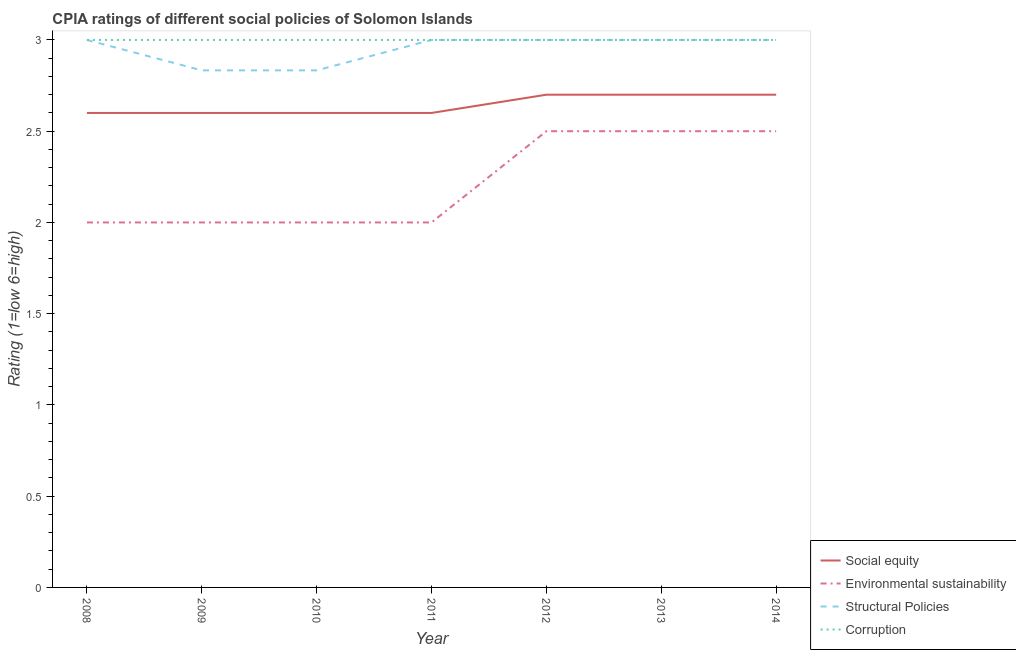Is the number of lines equal to the number of legend labels?
Ensure brevity in your answer.  Yes. Across all years, what is the maximum cpia rating of structural policies?
Your response must be concise. 3. Across all years, what is the minimum cpia rating of social equity?
Offer a very short reply. 2.6. In which year was the cpia rating of environmental sustainability maximum?
Provide a short and direct response. 2012. In which year was the cpia rating of corruption minimum?
Your answer should be very brief. 2008. What is the total cpia rating of social equity in the graph?
Your answer should be very brief. 18.5. What is the difference between the cpia rating of structural policies in 2009 and that in 2014?
Your answer should be compact. -0.17. What is the average cpia rating of environmental sustainability per year?
Your answer should be compact. 2.21. In the year 2011, what is the difference between the cpia rating of social equity and cpia rating of corruption?
Provide a short and direct response. -0.4. What is the ratio of the cpia rating of structural policies in 2010 to that in 2011?
Your answer should be very brief. 0.94. Is the difference between the cpia rating of environmental sustainability in 2008 and 2014 greater than the difference between the cpia rating of social equity in 2008 and 2014?
Make the answer very short. No. What is the difference between the highest and the second highest cpia rating of social equity?
Offer a very short reply. 0. What is the difference between the highest and the lowest cpia rating of structural policies?
Make the answer very short. 0.17. In how many years, is the cpia rating of corruption greater than the average cpia rating of corruption taken over all years?
Provide a succinct answer. 0. Is the sum of the cpia rating of environmental sustainability in 2008 and 2011 greater than the maximum cpia rating of corruption across all years?
Keep it short and to the point. Yes. Is it the case that in every year, the sum of the cpia rating of social equity and cpia rating of environmental sustainability is greater than the cpia rating of structural policies?
Offer a very short reply. Yes. What is the difference between two consecutive major ticks on the Y-axis?
Keep it short and to the point. 0.5. Does the graph contain any zero values?
Provide a succinct answer. No. Does the graph contain grids?
Offer a terse response. No. Where does the legend appear in the graph?
Offer a terse response. Bottom right. How many legend labels are there?
Your answer should be very brief. 4. How are the legend labels stacked?
Your answer should be very brief. Vertical. What is the title of the graph?
Your answer should be compact. CPIA ratings of different social policies of Solomon Islands. Does "Minerals" appear as one of the legend labels in the graph?
Give a very brief answer. No. What is the label or title of the Y-axis?
Offer a terse response. Rating (1=low 6=high). What is the Rating (1=low 6=high) of Corruption in 2008?
Provide a short and direct response. 3. What is the Rating (1=low 6=high) of Structural Policies in 2009?
Provide a short and direct response. 2.83. What is the Rating (1=low 6=high) of Corruption in 2009?
Give a very brief answer. 3. What is the Rating (1=low 6=high) of Structural Policies in 2010?
Provide a short and direct response. 2.83. What is the Rating (1=low 6=high) in Corruption in 2010?
Your response must be concise. 3. What is the Rating (1=low 6=high) in Environmental sustainability in 2011?
Provide a short and direct response. 2. What is the Rating (1=low 6=high) in Structural Policies in 2011?
Your answer should be compact. 3. What is the Rating (1=low 6=high) of Social equity in 2012?
Make the answer very short. 2.7. What is the Rating (1=low 6=high) in Environmental sustainability in 2012?
Provide a succinct answer. 2.5. What is the Rating (1=low 6=high) of Structural Policies in 2012?
Your answer should be very brief. 3. What is the Rating (1=low 6=high) in Structural Policies in 2013?
Your answer should be compact. 3. What is the Rating (1=low 6=high) in Social equity in 2014?
Ensure brevity in your answer.  2.7. Across all years, what is the minimum Rating (1=low 6=high) in Environmental sustainability?
Provide a succinct answer. 2. Across all years, what is the minimum Rating (1=low 6=high) in Structural Policies?
Provide a succinct answer. 2.83. Across all years, what is the minimum Rating (1=low 6=high) in Corruption?
Your answer should be very brief. 3. What is the total Rating (1=low 6=high) of Social equity in the graph?
Your response must be concise. 18.5. What is the total Rating (1=low 6=high) in Environmental sustainability in the graph?
Offer a terse response. 15.5. What is the total Rating (1=low 6=high) of Structural Policies in the graph?
Make the answer very short. 20.67. What is the difference between the Rating (1=low 6=high) of Social equity in 2008 and that in 2009?
Make the answer very short. 0. What is the difference between the Rating (1=low 6=high) of Environmental sustainability in 2008 and that in 2009?
Your answer should be very brief. 0. What is the difference between the Rating (1=low 6=high) of Corruption in 2008 and that in 2009?
Your answer should be very brief. 0. What is the difference between the Rating (1=low 6=high) of Environmental sustainability in 2008 and that in 2010?
Your answer should be very brief. 0. What is the difference between the Rating (1=low 6=high) in Corruption in 2008 and that in 2010?
Your answer should be compact. 0. What is the difference between the Rating (1=low 6=high) in Environmental sustainability in 2008 and that in 2011?
Your response must be concise. 0. What is the difference between the Rating (1=low 6=high) in Corruption in 2008 and that in 2012?
Offer a very short reply. 0. What is the difference between the Rating (1=low 6=high) of Social equity in 2008 and that in 2013?
Offer a terse response. -0.1. What is the difference between the Rating (1=low 6=high) in Environmental sustainability in 2008 and that in 2013?
Offer a terse response. -0.5. What is the difference between the Rating (1=low 6=high) in Corruption in 2008 and that in 2013?
Make the answer very short. 0. What is the difference between the Rating (1=low 6=high) of Environmental sustainability in 2008 and that in 2014?
Ensure brevity in your answer.  -0.5. What is the difference between the Rating (1=low 6=high) in Social equity in 2009 and that in 2011?
Provide a short and direct response. 0. What is the difference between the Rating (1=low 6=high) in Environmental sustainability in 2009 and that in 2011?
Offer a very short reply. 0. What is the difference between the Rating (1=low 6=high) of Structural Policies in 2009 and that in 2011?
Provide a short and direct response. -0.17. What is the difference between the Rating (1=low 6=high) of Social equity in 2009 and that in 2012?
Your answer should be compact. -0.1. What is the difference between the Rating (1=low 6=high) in Environmental sustainability in 2009 and that in 2012?
Your answer should be very brief. -0.5. What is the difference between the Rating (1=low 6=high) of Corruption in 2009 and that in 2012?
Make the answer very short. 0. What is the difference between the Rating (1=low 6=high) of Corruption in 2009 and that in 2013?
Provide a succinct answer. 0. What is the difference between the Rating (1=low 6=high) of Social equity in 2009 and that in 2014?
Provide a succinct answer. -0.1. What is the difference between the Rating (1=low 6=high) in Structural Policies in 2009 and that in 2014?
Your response must be concise. -0.17. What is the difference between the Rating (1=low 6=high) in Corruption in 2009 and that in 2014?
Your answer should be very brief. 0. What is the difference between the Rating (1=low 6=high) in Social equity in 2010 and that in 2011?
Offer a very short reply. 0. What is the difference between the Rating (1=low 6=high) in Structural Policies in 2010 and that in 2011?
Give a very brief answer. -0.17. What is the difference between the Rating (1=low 6=high) of Corruption in 2010 and that in 2011?
Your answer should be very brief. 0. What is the difference between the Rating (1=low 6=high) in Social equity in 2010 and that in 2012?
Your answer should be compact. -0.1. What is the difference between the Rating (1=low 6=high) in Structural Policies in 2010 and that in 2012?
Offer a terse response. -0.17. What is the difference between the Rating (1=low 6=high) in Corruption in 2010 and that in 2012?
Offer a terse response. 0. What is the difference between the Rating (1=low 6=high) in Social equity in 2010 and that in 2013?
Make the answer very short. -0.1. What is the difference between the Rating (1=low 6=high) of Environmental sustainability in 2010 and that in 2013?
Keep it short and to the point. -0.5. What is the difference between the Rating (1=low 6=high) of Corruption in 2010 and that in 2013?
Your response must be concise. 0. What is the difference between the Rating (1=low 6=high) of Corruption in 2010 and that in 2014?
Your response must be concise. 0. What is the difference between the Rating (1=low 6=high) of Social equity in 2011 and that in 2012?
Offer a very short reply. -0.1. What is the difference between the Rating (1=low 6=high) in Environmental sustainability in 2011 and that in 2012?
Your answer should be very brief. -0.5. What is the difference between the Rating (1=low 6=high) in Corruption in 2011 and that in 2012?
Give a very brief answer. 0. What is the difference between the Rating (1=low 6=high) of Social equity in 2011 and that in 2013?
Your response must be concise. -0.1. What is the difference between the Rating (1=low 6=high) of Structural Policies in 2011 and that in 2013?
Your answer should be very brief. 0. What is the difference between the Rating (1=low 6=high) of Corruption in 2011 and that in 2013?
Your answer should be compact. 0. What is the difference between the Rating (1=low 6=high) in Corruption in 2011 and that in 2014?
Your answer should be compact. 0. What is the difference between the Rating (1=low 6=high) of Social equity in 2012 and that in 2013?
Offer a very short reply. 0. What is the difference between the Rating (1=low 6=high) of Environmental sustainability in 2012 and that in 2013?
Your response must be concise. 0. What is the difference between the Rating (1=low 6=high) of Structural Policies in 2012 and that in 2013?
Provide a short and direct response. 0. What is the difference between the Rating (1=low 6=high) in Social equity in 2012 and that in 2014?
Keep it short and to the point. 0. What is the difference between the Rating (1=low 6=high) in Environmental sustainability in 2012 and that in 2014?
Your answer should be compact. 0. What is the difference between the Rating (1=low 6=high) of Structural Policies in 2012 and that in 2014?
Your answer should be compact. 0. What is the difference between the Rating (1=low 6=high) of Environmental sustainability in 2013 and that in 2014?
Provide a succinct answer. 0. What is the difference between the Rating (1=low 6=high) of Corruption in 2013 and that in 2014?
Make the answer very short. 0. What is the difference between the Rating (1=low 6=high) of Social equity in 2008 and the Rating (1=low 6=high) of Environmental sustainability in 2009?
Your answer should be very brief. 0.6. What is the difference between the Rating (1=low 6=high) in Social equity in 2008 and the Rating (1=low 6=high) in Structural Policies in 2009?
Give a very brief answer. -0.23. What is the difference between the Rating (1=low 6=high) in Social equity in 2008 and the Rating (1=low 6=high) in Corruption in 2009?
Ensure brevity in your answer.  -0.4. What is the difference between the Rating (1=low 6=high) in Environmental sustainability in 2008 and the Rating (1=low 6=high) in Structural Policies in 2009?
Provide a short and direct response. -0.83. What is the difference between the Rating (1=low 6=high) of Environmental sustainability in 2008 and the Rating (1=low 6=high) of Corruption in 2009?
Offer a very short reply. -1. What is the difference between the Rating (1=low 6=high) of Social equity in 2008 and the Rating (1=low 6=high) of Environmental sustainability in 2010?
Provide a succinct answer. 0.6. What is the difference between the Rating (1=low 6=high) in Social equity in 2008 and the Rating (1=low 6=high) in Structural Policies in 2010?
Your response must be concise. -0.23. What is the difference between the Rating (1=low 6=high) in Environmental sustainability in 2008 and the Rating (1=low 6=high) in Structural Policies in 2010?
Give a very brief answer. -0.83. What is the difference between the Rating (1=low 6=high) of Environmental sustainability in 2008 and the Rating (1=low 6=high) of Corruption in 2010?
Provide a succinct answer. -1. What is the difference between the Rating (1=low 6=high) of Social equity in 2008 and the Rating (1=low 6=high) of Environmental sustainability in 2011?
Make the answer very short. 0.6. What is the difference between the Rating (1=low 6=high) of Social equity in 2008 and the Rating (1=low 6=high) of Structural Policies in 2011?
Your answer should be very brief. -0.4. What is the difference between the Rating (1=low 6=high) in Social equity in 2008 and the Rating (1=low 6=high) in Corruption in 2011?
Offer a very short reply. -0.4. What is the difference between the Rating (1=low 6=high) of Environmental sustainability in 2008 and the Rating (1=low 6=high) of Corruption in 2011?
Provide a short and direct response. -1. What is the difference between the Rating (1=low 6=high) in Structural Policies in 2008 and the Rating (1=low 6=high) in Corruption in 2011?
Your answer should be compact. 0. What is the difference between the Rating (1=low 6=high) in Social equity in 2008 and the Rating (1=low 6=high) in Structural Policies in 2012?
Provide a short and direct response. -0.4. What is the difference between the Rating (1=low 6=high) in Social equity in 2008 and the Rating (1=low 6=high) in Corruption in 2012?
Your answer should be compact. -0.4. What is the difference between the Rating (1=low 6=high) of Environmental sustainability in 2008 and the Rating (1=low 6=high) of Corruption in 2012?
Provide a succinct answer. -1. What is the difference between the Rating (1=low 6=high) in Social equity in 2008 and the Rating (1=low 6=high) in Environmental sustainability in 2013?
Offer a terse response. 0.1. What is the difference between the Rating (1=low 6=high) in Environmental sustainability in 2008 and the Rating (1=low 6=high) in Structural Policies in 2013?
Your answer should be compact. -1. What is the difference between the Rating (1=low 6=high) in Environmental sustainability in 2008 and the Rating (1=low 6=high) in Corruption in 2013?
Ensure brevity in your answer.  -1. What is the difference between the Rating (1=low 6=high) in Social equity in 2008 and the Rating (1=low 6=high) in Corruption in 2014?
Offer a terse response. -0.4. What is the difference between the Rating (1=low 6=high) in Environmental sustainability in 2008 and the Rating (1=low 6=high) in Corruption in 2014?
Offer a terse response. -1. What is the difference between the Rating (1=low 6=high) of Structural Policies in 2008 and the Rating (1=low 6=high) of Corruption in 2014?
Give a very brief answer. 0. What is the difference between the Rating (1=low 6=high) of Social equity in 2009 and the Rating (1=low 6=high) of Structural Policies in 2010?
Your answer should be compact. -0.23. What is the difference between the Rating (1=low 6=high) in Social equity in 2009 and the Rating (1=low 6=high) in Corruption in 2010?
Your answer should be very brief. -0.4. What is the difference between the Rating (1=low 6=high) of Environmental sustainability in 2009 and the Rating (1=low 6=high) of Structural Policies in 2010?
Give a very brief answer. -0.83. What is the difference between the Rating (1=low 6=high) of Social equity in 2009 and the Rating (1=low 6=high) of Structural Policies in 2011?
Make the answer very short. -0.4. What is the difference between the Rating (1=low 6=high) of Environmental sustainability in 2009 and the Rating (1=low 6=high) of Structural Policies in 2011?
Provide a succinct answer. -1. What is the difference between the Rating (1=low 6=high) in Environmental sustainability in 2009 and the Rating (1=low 6=high) in Corruption in 2011?
Offer a terse response. -1. What is the difference between the Rating (1=low 6=high) in Structural Policies in 2009 and the Rating (1=low 6=high) in Corruption in 2011?
Ensure brevity in your answer.  -0.17. What is the difference between the Rating (1=low 6=high) in Social equity in 2009 and the Rating (1=low 6=high) in Environmental sustainability in 2012?
Provide a short and direct response. 0.1. What is the difference between the Rating (1=low 6=high) of Social equity in 2009 and the Rating (1=low 6=high) of Structural Policies in 2012?
Your response must be concise. -0.4. What is the difference between the Rating (1=low 6=high) of Social equity in 2009 and the Rating (1=low 6=high) of Corruption in 2012?
Your response must be concise. -0.4. What is the difference between the Rating (1=low 6=high) of Environmental sustainability in 2009 and the Rating (1=low 6=high) of Structural Policies in 2012?
Keep it short and to the point. -1. What is the difference between the Rating (1=low 6=high) of Social equity in 2009 and the Rating (1=low 6=high) of Environmental sustainability in 2013?
Ensure brevity in your answer.  0.1. What is the difference between the Rating (1=low 6=high) of Social equity in 2009 and the Rating (1=low 6=high) of Corruption in 2013?
Offer a terse response. -0.4. What is the difference between the Rating (1=low 6=high) in Environmental sustainability in 2009 and the Rating (1=low 6=high) in Structural Policies in 2013?
Provide a short and direct response. -1. What is the difference between the Rating (1=low 6=high) of Social equity in 2009 and the Rating (1=low 6=high) of Structural Policies in 2014?
Your response must be concise. -0.4. What is the difference between the Rating (1=low 6=high) in Environmental sustainability in 2009 and the Rating (1=low 6=high) in Structural Policies in 2014?
Ensure brevity in your answer.  -1. What is the difference between the Rating (1=low 6=high) of Environmental sustainability in 2009 and the Rating (1=low 6=high) of Corruption in 2014?
Offer a very short reply. -1. What is the difference between the Rating (1=low 6=high) in Structural Policies in 2009 and the Rating (1=low 6=high) in Corruption in 2014?
Your answer should be very brief. -0.17. What is the difference between the Rating (1=low 6=high) in Social equity in 2010 and the Rating (1=low 6=high) in Structural Policies in 2011?
Provide a short and direct response. -0.4. What is the difference between the Rating (1=low 6=high) in Social equity in 2010 and the Rating (1=low 6=high) in Corruption in 2011?
Offer a very short reply. -0.4. What is the difference between the Rating (1=low 6=high) in Structural Policies in 2010 and the Rating (1=low 6=high) in Corruption in 2011?
Provide a short and direct response. -0.17. What is the difference between the Rating (1=low 6=high) of Social equity in 2010 and the Rating (1=low 6=high) of Structural Policies in 2012?
Make the answer very short. -0.4. What is the difference between the Rating (1=low 6=high) in Environmental sustainability in 2010 and the Rating (1=low 6=high) in Structural Policies in 2012?
Keep it short and to the point. -1. What is the difference between the Rating (1=low 6=high) in Environmental sustainability in 2010 and the Rating (1=low 6=high) in Corruption in 2012?
Provide a short and direct response. -1. What is the difference between the Rating (1=low 6=high) in Structural Policies in 2010 and the Rating (1=low 6=high) in Corruption in 2012?
Make the answer very short. -0.17. What is the difference between the Rating (1=low 6=high) in Social equity in 2010 and the Rating (1=low 6=high) in Corruption in 2013?
Provide a short and direct response. -0.4. What is the difference between the Rating (1=low 6=high) in Environmental sustainability in 2010 and the Rating (1=low 6=high) in Structural Policies in 2013?
Provide a short and direct response. -1. What is the difference between the Rating (1=low 6=high) of Structural Policies in 2010 and the Rating (1=low 6=high) of Corruption in 2013?
Ensure brevity in your answer.  -0.17. What is the difference between the Rating (1=low 6=high) of Social equity in 2010 and the Rating (1=low 6=high) of Structural Policies in 2014?
Provide a short and direct response. -0.4. What is the difference between the Rating (1=low 6=high) of Social equity in 2010 and the Rating (1=low 6=high) of Corruption in 2014?
Ensure brevity in your answer.  -0.4. What is the difference between the Rating (1=low 6=high) in Environmental sustainability in 2010 and the Rating (1=low 6=high) in Structural Policies in 2014?
Your answer should be compact. -1. What is the difference between the Rating (1=low 6=high) of Social equity in 2011 and the Rating (1=low 6=high) of Environmental sustainability in 2012?
Offer a terse response. 0.1. What is the difference between the Rating (1=low 6=high) of Social equity in 2011 and the Rating (1=low 6=high) of Structural Policies in 2012?
Keep it short and to the point. -0.4. What is the difference between the Rating (1=low 6=high) in Structural Policies in 2011 and the Rating (1=low 6=high) in Corruption in 2012?
Offer a very short reply. 0. What is the difference between the Rating (1=low 6=high) of Social equity in 2011 and the Rating (1=low 6=high) of Environmental sustainability in 2013?
Your answer should be very brief. 0.1. What is the difference between the Rating (1=low 6=high) of Social equity in 2011 and the Rating (1=low 6=high) of Structural Policies in 2013?
Keep it short and to the point. -0.4. What is the difference between the Rating (1=low 6=high) in Environmental sustainability in 2011 and the Rating (1=low 6=high) in Structural Policies in 2013?
Provide a short and direct response. -1. What is the difference between the Rating (1=low 6=high) of Environmental sustainability in 2011 and the Rating (1=low 6=high) of Corruption in 2013?
Your answer should be compact. -1. What is the difference between the Rating (1=low 6=high) of Structural Policies in 2011 and the Rating (1=low 6=high) of Corruption in 2013?
Provide a short and direct response. 0. What is the difference between the Rating (1=low 6=high) of Social equity in 2011 and the Rating (1=low 6=high) of Environmental sustainability in 2014?
Provide a short and direct response. 0.1. What is the difference between the Rating (1=low 6=high) in Social equity in 2012 and the Rating (1=low 6=high) in Environmental sustainability in 2013?
Provide a short and direct response. 0.2. What is the difference between the Rating (1=low 6=high) of Social equity in 2012 and the Rating (1=low 6=high) of Structural Policies in 2013?
Keep it short and to the point. -0.3. What is the difference between the Rating (1=low 6=high) in Environmental sustainability in 2012 and the Rating (1=low 6=high) in Structural Policies in 2013?
Make the answer very short. -0.5. What is the difference between the Rating (1=low 6=high) of Structural Policies in 2012 and the Rating (1=low 6=high) of Corruption in 2013?
Offer a terse response. 0. What is the difference between the Rating (1=low 6=high) of Social equity in 2012 and the Rating (1=low 6=high) of Environmental sustainability in 2014?
Ensure brevity in your answer.  0.2. What is the difference between the Rating (1=low 6=high) of Environmental sustainability in 2012 and the Rating (1=low 6=high) of Structural Policies in 2014?
Provide a short and direct response. -0.5. What is the difference between the Rating (1=low 6=high) of Structural Policies in 2012 and the Rating (1=low 6=high) of Corruption in 2014?
Ensure brevity in your answer.  0. What is the difference between the Rating (1=low 6=high) of Social equity in 2013 and the Rating (1=low 6=high) of Environmental sustainability in 2014?
Provide a succinct answer. 0.2. What is the difference between the Rating (1=low 6=high) of Structural Policies in 2013 and the Rating (1=low 6=high) of Corruption in 2014?
Your answer should be compact. 0. What is the average Rating (1=low 6=high) in Social equity per year?
Give a very brief answer. 2.64. What is the average Rating (1=low 6=high) in Environmental sustainability per year?
Your answer should be compact. 2.21. What is the average Rating (1=low 6=high) in Structural Policies per year?
Your response must be concise. 2.95. What is the average Rating (1=low 6=high) in Corruption per year?
Your answer should be very brief. 3. In the year 2008, what is the difference between the Rating (1=low 6=high) in Social equity and Rating (1=low 6=high) in Corruption?
Ensure brevity in your answer.  -0.4. In the year 2008, what is the difference between the Rating (1=low 6=high) of Structural Policies and Rating (1=low 6=high) of Corruption?
Ensure brevity in your answer.  0. In the year 2009, what is the difference between the Rating (1=low 6=high) in Social equity and Rating (1=low 6=high) in Environmental sustainability?
Your answer should be compact. 0.6. In the year 2009, what is the difference between the Rating (1=low 6=high) of Social equity and Rating (1=low 6=high) of Structural Policies?
Give a very brief answer. -0.23. In the year 2009, what is the difference between the Rating (1=low 6=high) in Social equity and Rating (1=low 6=high) in Corruption?
Offer a very short reply. -0.4. In the year 2009, what is the difference between the Rating (1=low 6=high) in Environmental sustainability and Rating (1=low 6=high) in Structural Policies?
Your answer should be very brief. -0.83. In the year 2009, what is the difference between the Rating (1=low 6=high) of Structural Policies and Rating (1=low 6=high) of Corruption?
Your response must be concise. -0.17. In the year 2010, what is the difference between the Rating (1=low 6=high) in Social equity and Rating (1=low 6=high) in Environmental sustainability?
Your answer should be very brief. 0.6. In the year 2010, what is the difference between the Rating (1=low 6=high) of Social equity and Rating (1=low 6=high) of Structural Policies?
Ensure brevity in your answer.  -0.23. In the year 2010, what is the difference between the Rating (1=low 6=high) in Social equity and Rating (1=low 6=high) in Corruption?
Make the answer very short. -0.4. In the year 2010, what is the difference between the Rating (1=low 6=high) in Environmental sustainability and Rating (1=low 6=high) in Corruption?
Keep it short and to the point. -1. In the year 2010, what is the difference between the Rating (1=low 6=high) of Structural Policies and Rating (1=low 6=high) of Corruption?
Offer a very short reply. -0.17. In the year 2011, what is the difference between the Rating (1=low 6=high) in Social equity and Rating (1=low 6=high) in Environmental sustainability?
Your response must be concise. 0.6. In the year 2011, what is the difference between the Rating (1=low 6=high) of Social equity and Rating (1=low 6=high) of Structural Policies?
Your answer should be very brief. -0.4. In the year 2012, what is the difference between the Rating (1=low 6=high) in Social equity and Rating (1=low 6=high) in Environmental sustainability?
Your answer should be very brief. 0.2. In the year 2012, what is the difference between the Rating (1=low 6=high) of Environmental sustainability and Rating (1=low 6=high) of Structural Policies?
Make the answer very short. -0.5. In the year 2012, what is the difference between the Rating (1=low 6=high) in Structural Policies and Rating (1=low 6=high) in Corruption?
Keep it short and to the point. 0. In the year 2013, what is the difference between the Rating (1=low 6=high) in Social equity and Rating (1=low 6=high) in Environmental sustainability?
Offer a terse response. 0.2. In the year 2013, what is the difference between the Rating (1=low 6=high) of Environmental sustainability and Rating (1=low 6=high) of Structural Policies?
Make the answer very short. -0.5. In the year 2014, what is the difference between the Rating (1=low 6=high) of Social equity and Rating (1=low 6=high) of Structural Policies?
Offer a terse response. -0.3. In the year 2014, what is the difference between the Rating (1=low 6=high) of Social equity and Rating (1=low 6=high) of Corruption?
Ensure brevity in your answer.  -0.3. In the year 2014, what is the difference between the Rating (1=low 6=high) of Structural Policies and Rating (1=low 6=high) of Corruption?
Provide a short and direct response. 0. What is the ratio of the Rating (1=low 6=high) in Social equity in 2008 to that in 2009?
Your answer should be compact. 1. What is the ratio of the Rating (1=low 6=high) in Environmental sustainability in 2008 to that in 2009?
Ensure brevity in your answer.  1. What is the ratio of the Rating (1=low 6=high) of Structural Policies in 2008 to that in 2009?
Make the answer very short. 1.06. What is the ratio of the Rating (1=low 6=high) of Corruption in 2008 to that in 2009?
Provide a short and direct response. 1. What is the ratio of the Rating (1=low 6=high) in Social equity in 2008 to that in 2010?
Offer a terse response. 1. What is the ratio of the Rating (1=low 6=high) of Structural Policies in 2008 to that in 2010?
Provide a short and direct response. 1.06. What is the ratio of the Rating (1=low 6=high) of Social equity in 2008 to that in 2011?
Provide a succinct answer. 1. What is the ratio of the Rating (1=low 6=high) in Structural Policies in 2008 to that in 2011?
Your response must be concise. 1. What is the ratio of the Rating (1=low 6=high) in Corruption in 2008 to that in 2011?
Offer a very short reply. 1. What is the ratio of the Rating (1=low 6=high) in Social equity in 2008 to that in 2012?
Offer a terse response. 0.96. What is the ratio of the Rating (1=low 6=high) of Environmental sustainability in 2008 to that in 2012?
Your answer should be very brief. 0.8. What is the ratio of the Rating (1=low 6=high) of Corruption in 2008 to that in 2012?
Ensure brevity in your answer.  1. What is the ratio of the Rating (1=low 6=high) in Structural Policies in 2008 to that in 2014?
Your answer should be compact. 1. What is the ratio of the Rating (1=low 6=high) of Environmental sustainability in 2009 to that in 2010?
Ensure brevity in your answer.  1. What is the ratio of the Rating (1=low 6=high) of Corruption in 2009 to that in 2010?
Your answer should be compact. 1. What is the ratio of the Rating (1=low 6=high) in Social equity in 2009 to that in 2012?
Provide a succinct answer. 0.96. What is the ratio of the Rating (1=low 6=high) of Structural Policies in 2009 to that in 2012?
Offer a very short reply. 0.94. What is the ratio of the Rating (1=low 6=high) in Social equity in 2009 to that in 2013?
Provide a short and direct response. 0.96. What is the ratio of the Rating (1=low 6=high) in Structural Policies in 2009 to that in 2013?
Provide a succinct answer. 0.94. What is the ratio of the Rating (1=low 6=high) in Corruption in 2009 to that in 2013?
Give a very brief answer. 1. What is the ratio of the Rating (1=low 6=high) in Social equity in 2009 to that in 2014?
Offer a very short reply. 0.96. What is the ratio of the Rating (1=low 6=high) of Structural Policies in 2009 to that in 2014?
Keep it short and to the point. 0.94. What is the ratio of the Rating (1=low 6=high) in Environmental sustainability in 2010 to that in 2011?
Provide a succinct answer. 1. What is the ratio of the Rating (1=low 6=high) of Structural Policies in 2010 to that in 2011?
Ensure brevity in your answer.  0.94. What is the ratio of the Rating (1=low 6=high) in Structural Policies in 2010 to that in 2012?
Ensure brevity in your answer.  0.94. What is the ratio of the Rating (1=low 6=high) in Corruption in 2010 to that in 2012?
Ensure brevity in your answer.  1. What is the ratio of the Rating (1=low 6=high) in Structural Policies in 2010 to that in 2013?
Provide a succinct answer. 0.94. What is the ratio of the Rating (1=low 6=high) of Social equity in 2010 to that in 2014?
Your answer should be very brief. 0.96. What is the ratio of the Rating (1=low 6=high) in Structural Policies in 2010 to that in 2014?
Your response must be concise. 0.94. What is the ratio of the Rating (1=low 6=high) in Social equity in 2011 to that in 2012?
Offer a terse response. 0.96. What is the ratio of the Rating (1=low 6=high) of Structural Policies in 2011 to that in 2013?
Provide a short and direct response. 1. What is the ratio of the Rating (1=low 6=high) of Social equity in 2011 to that in 2014?
Offer a very short reply. 0.96. What is the ratio of the Rating (1=low 6=high) in Environmental sustainability in 2011 to that in 2014?
Keep it short and to the point. 0.8. What is the ratio of the Rating (1=low 6=high) in Corruption in 2011 to that in 2014?
Offer a very short reply. 1. What is the ratio of the Rating (1=low 6=high) of Social equity in 2012 to that in 2013?
Keep it short and to the point. 1. What is the ratio of the Rating (1=low 6=high) in Social equity in 2012 to that in 2014?
Make the answer very short. 1. What is the ratio of the Rating (1=low 6=high) of Structural Policies in 2012 to that in 2014?
Provide a short and direct response. 1. What is the ratio of the Rating (1=low 6=high) of Environmental sustainability in 2013 to that in 2014?
Make the answer very short. 1. What is the ratio of the Rating (1=low 6=high) in Corruption in 2013 to that in 2014?
Make the answer very short. 1. What is the difference between the highest and the second highest Rating (1=low 6=high) in Social equity?
Ensure brevity in your answer.  0. What is the difference between the highest and the second highest Rating (1=low 6=high) of Environmental sustainability?
Provide a short and direct response. 0. What is the difference between the highest and the lowest Rating (1=low 6=high) in Social equity?
Offer a terse response. 0.1. What is the difference between the highest and the lowest Rating (1=low 6=high) in Structural Policies?
Offer a terse response. 0.17. What is the difference between the highest and the lowest Rating (1=low 6=high) of Corruption?
Your answer should be very brief. 0. 